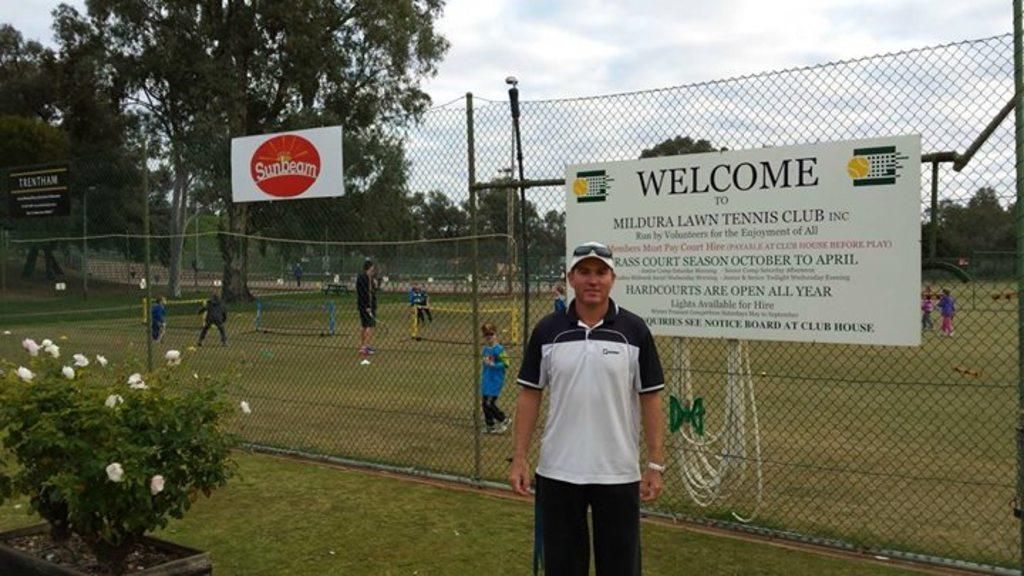<image>
Provide a brief description of the given image. A man stands in front of a sign that welcomes people to Mildura Lawn Tennis Club. 